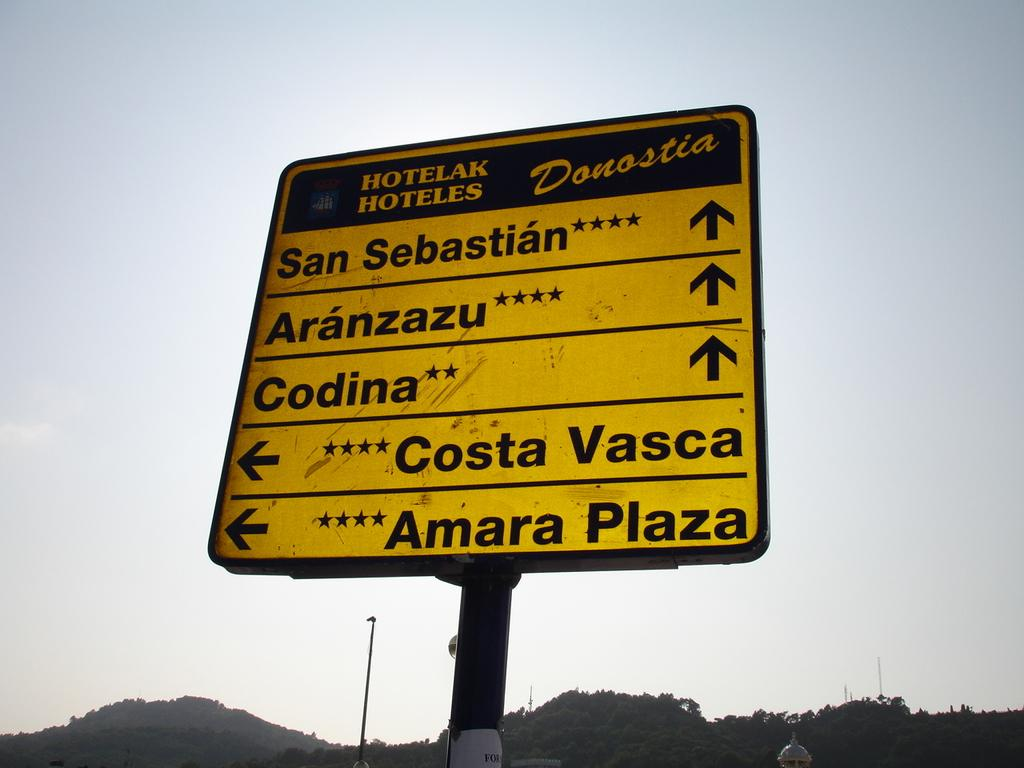Provide a one-sentence caption for the provided image. Sign with places to go and hotels located in the city. 